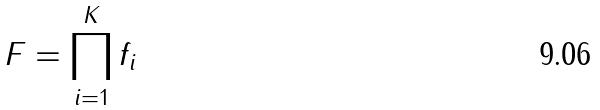<formula> <loc_0><loc_0><loc_500><loc_500>F = \prod _ { i = 1 } ^ { K } f _ { i }</formula> 